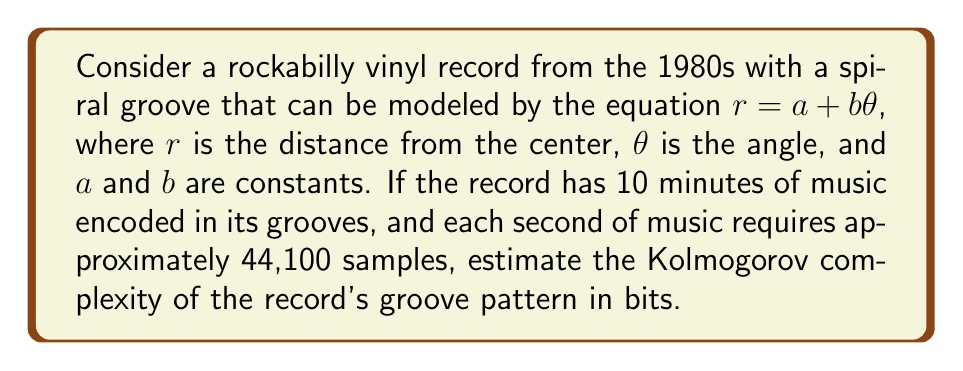Teach me how to tackle this problem. To estimate the Kolmogorov complexity of the vinyl record's groove pattern, we need to consider the following steps:

1) First, let's calculate the total number of samples:
   10 minutes = 600 seconds
   Total samples = 600 * 44,100 = 26,460,000

2) Each sample typically requires 16 bits (2 bytes) to encode the amplitude of the sound wave:
   Total bits = 26,460,000 * 16 = 423,360,000 bits

3) The groove pattern is essentially encoding this information. However, the Kolmogorov complexity is concerned with the shortest possible program that could generate this pattern.

4) The spiral groove can be described by the equation $r = a + b\theta$. This equation is very simple and can be encoded in a few bytes.

5) The actual complexity comes from the variations in the groove that encode the music. These variations can be thought of as deviations from the perfect spiral.

6) Rockabilly music from the 1980s, while complex, often features repetitive patterns and structures. This repetition can be exploited to compress the data.

7) A reasonable compression ratio for music is about 10:1. This means we might be able to describe the groove pattern with about 1/10th of the original data.

8) Estimated Kolmogorov complexity:
   $$K \approx \frac{423,360,000}{10} = 42,336,000 \text{ bits}$$

9) This is still a high estimate, as a more sophisticated compression algorithm tailored to the specific characteristics of rockabilly music might achieve even better compression.
Answer: The estimated Kolmogorov complexity of the vinyl record's groove pattern is approximately 42,336,000 bits. 